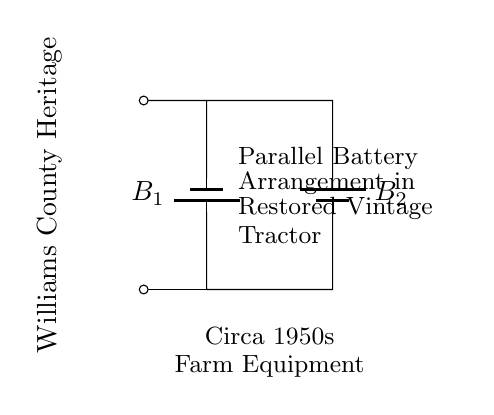What are the components shown in the circuit? The circuit diagram depicts two batteries connected in parallel. Each battery is labeled B1 and B2, indicating their respective identities.
Answer: Two batteries What is the significance of the parallel arrangement in this circuit? The parallel arrangement allows each battery to provide the same voltage while increasing the total current capacity. This enables the tractor to operate efficiently as both batteries share the load.
Answer: Increased current capacity What is the total voltage provided by the batteries? In a parallel circuit, the voltage remains the same as that of the individual batteries. Therefore, if we assume each battery is rated at 6V, the total voltage remains 6V.
Answer: 6V How does the parallel configuration affect battery lifespan? Using a parallel configuration can enhance battery lifespan because load current is distributed across both batteries, reducing strain on each one, thus prolonging their overall usage.
Answer: Prolongs lifespan What is the purpose of including more than one battery in this vintage tractor? The purpose of including additional batteries is to ensure reliable starting and operation under heavy loads, as vintage tractors often require more power than a single battery can provide.
Answer: Reliable power supply 